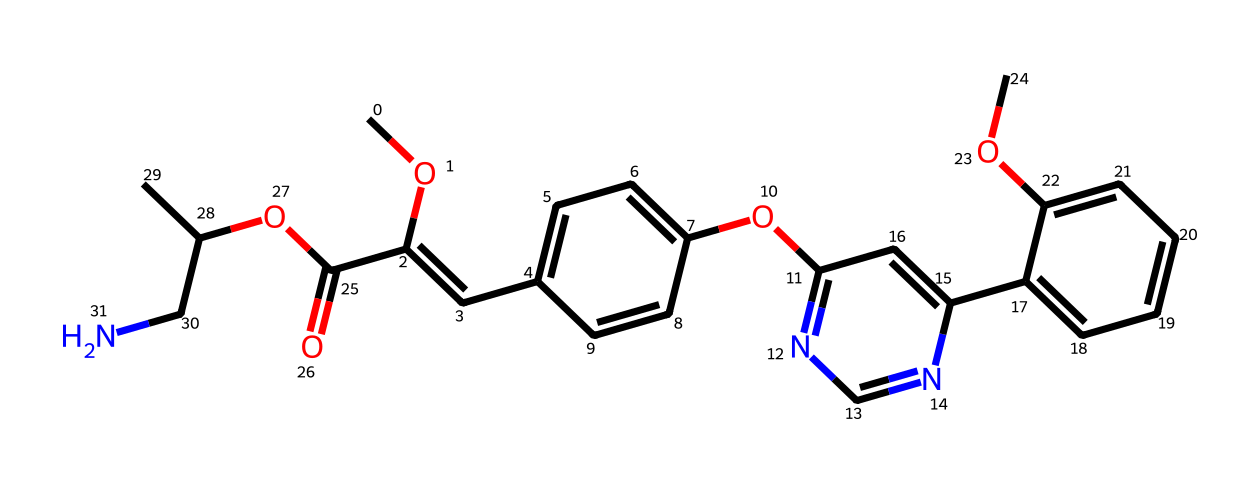How many carbon atoms are present in azoxystrobin? Count the carbon atoms represented in the SMILES notation; there are 18 carbon atoms scattered throughout the structure.
Answer: 18 What is the primary functional group present in azoxystrobin? The presence of “C(=O)” in the structure indicates the existence of a carbonyl group, which characterizes the ester functional group.
Answer: ester Identify the type of heterocycles present in the azoxystrobin structure. The nitrogen atoms in the structure point toward the involvement of pyrimidine and pyridine rings, which are common heterocycles featuring nitrogen atoms in aromatic systems.
Answer: pyrimidine and pyridine What is the molecular weight range of azoxystrobin? Analyzing the chemical structure allows the calculation of the molecular weight, which is typically around 401.4 g/mol based on the sum of the atomic weights of all atoms present.
Answer: 401.4 What role does the methoxy group play in the activity of azoxystrobin? The presence of methoxy groups (“–OCH3”) often enhances solubility and contributes to the stability and effectiveness of fungicides like azoxystrobin by participating in molecular interactions.
Answer: enhances solubility What type of chemical bonds are dominantly present in azoxystrobin? The SMILES structure reflects a combination of single and double bonds, with aromatic rings suggesting resonance and conjugation, which are key in its overall effectiveness as a fungicide.
Answer: covalent bonds 